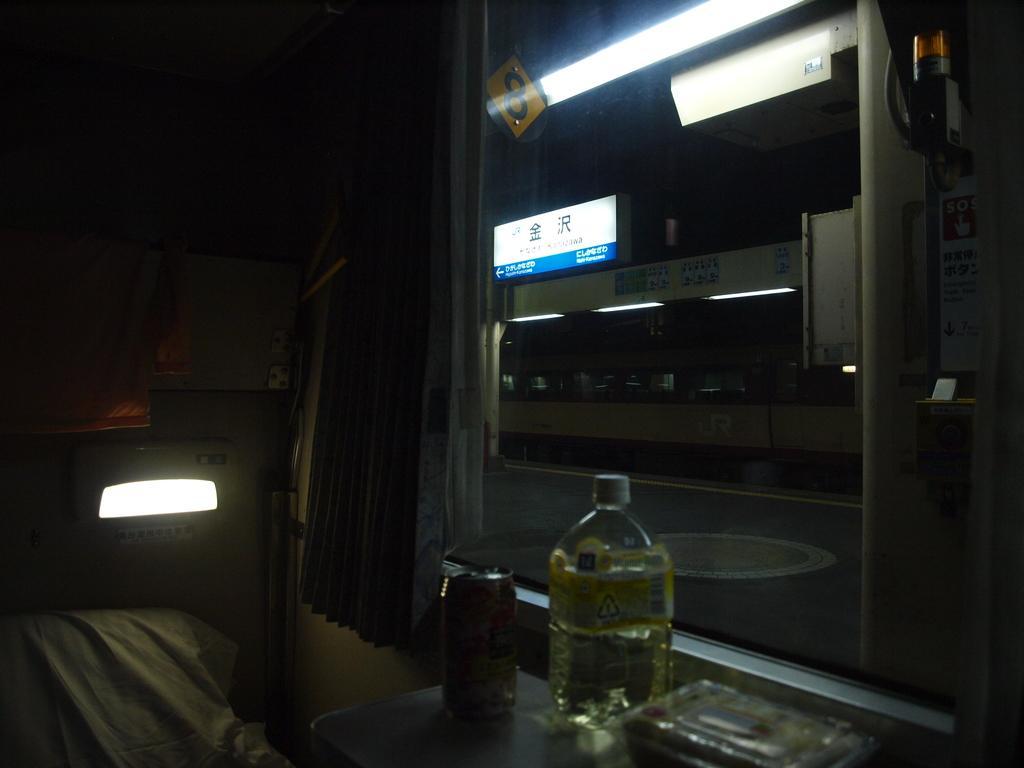Could you give a brief overview of what you see in this image? In this picture we can see a bottle,tin,light and a screen. 